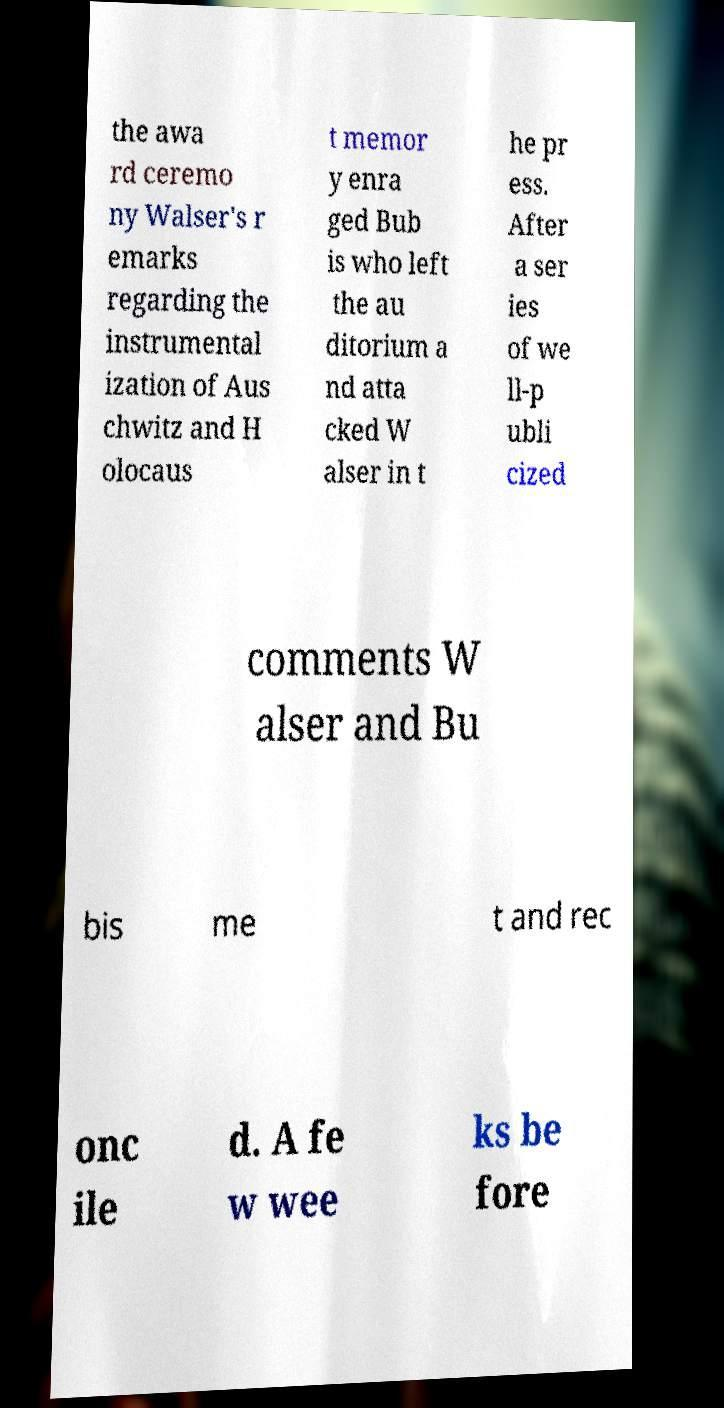Could you extract and type out the text from this image? the awa rd ceremo ny Walser's r emarks regarding the instrumental ization of Aus chwitz and H olocaus t memor y enra ged Bub is who left the au ditorium a nd atta cked W alser in t he pr ess. After a ser ies of we ll-p ubli cized comments W alser and Bu bis me t and rec onc ile d. A fe w wee ks be fore 